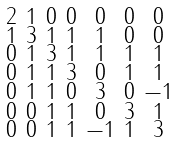Convert formula to latex. <formula><loc_0><loc_0><loc_500><loc_500>\begin{smallmatrix} 2 & 1 & 0 & 0 & 0 & 0 & 0 \\ 1 & 3 & 1 & 1 & 1 & 0 & 0 \\ 0 & 1 & 3 & 1 & 1 & 1 & 1 \\ 0 & 1 & 1 & 3 & 0 & 1 & 1 \\ 0 & 1 & 1 & 0 & 3 & 0 & - 1 \\ 0 & 0 & 1 & 1 & 0 & 3 & 1 \\ 0 & 0 & 1 & 1 & - 1 & 1 & 3 \end{smallmatrix}</formula> 